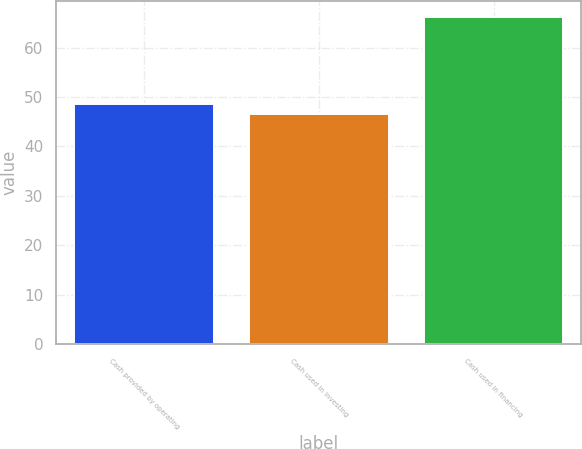<chart> <loc_0><loc_0><loc_500><loc_500><bar_chart><fcel>Cash provided by operating<fcel>Cash used in investing<fcel>Cash used in financing<nl><fcel>48.56<fcel>46.6<fcel>66.2<nl></chart> 